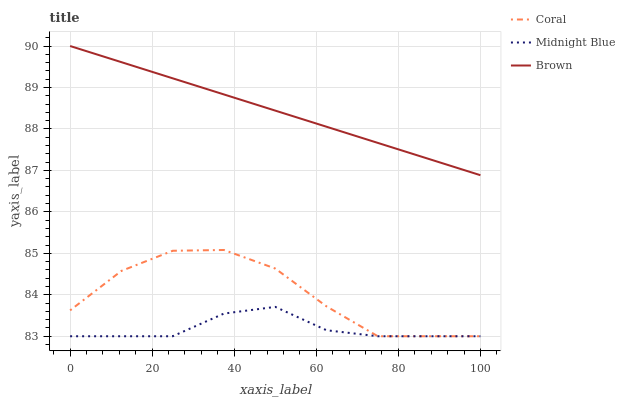Does Midnight Blue have the minimum area under the curve?
Answer yes or no. Yes. Does Brown have the maximum area under the curve?
Answer yes or no. Yes. Does Coral have the minimum area under the curve?
Answer yes or no. No. Does Coral have the maximum area under the curve?
Answer yes or no. No. Is Brown the smoothest?
Answer yes or no. Yes. Is Coral the roughest?
Answer yes or no. Yes. Is Midnight Blue the smoothest?
Answer yes or no. No. Is Midnight Blue the roughest?
Answer yes or no. No. Does Coral have the lowest value?
Answer yes or no. Yes. Does Brown have the highest value?
Answer yes or no. Yes. Does Coral have the highest value?
Answer yes or no. No. Is Midnight Blue less than Brown?
Answer yes or no. Yes. Is Brown greater than Midnight Blue?
Answer yes or no. Yes. Does Coral intersect Midnight Blue?
Answer yes or no. Yes. Is Coral less than Midnight Blue?
Answer yes or no. No. Is Coral greater than Midnight Blue?
Answer yes or no. No. Does Midnight Blue intersect Brown?
Answer yes or no. No. 